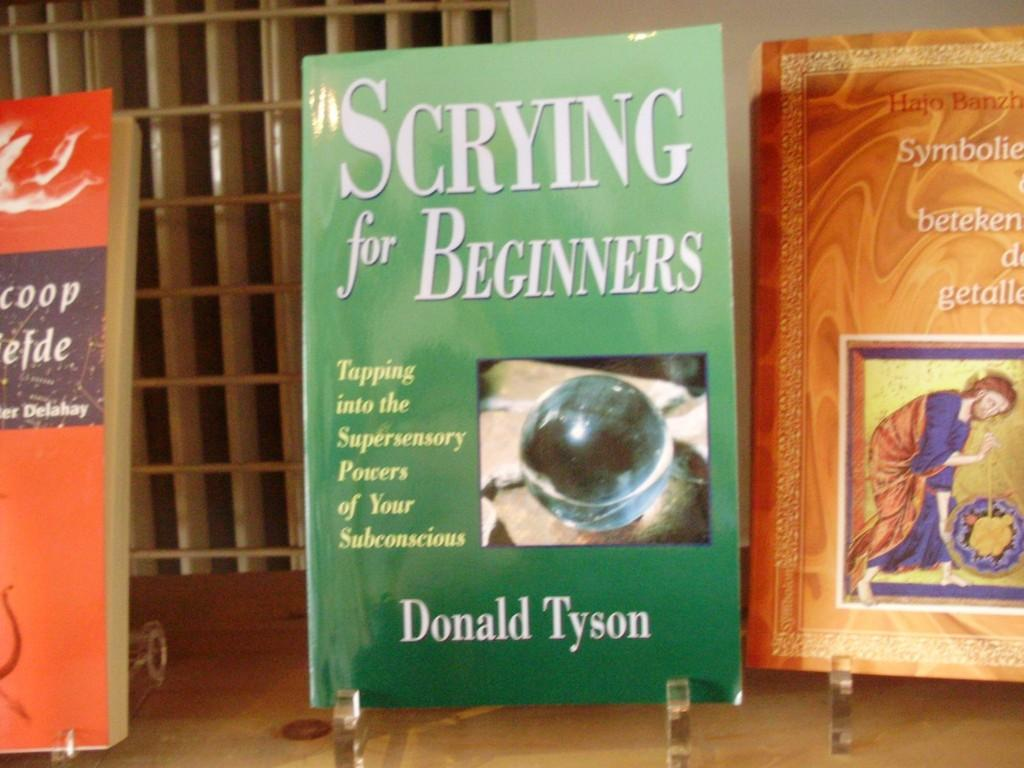<image>
Present a compact description of the photo's key features. Green book titled Scrying for Beginners by Donald Tyson. 